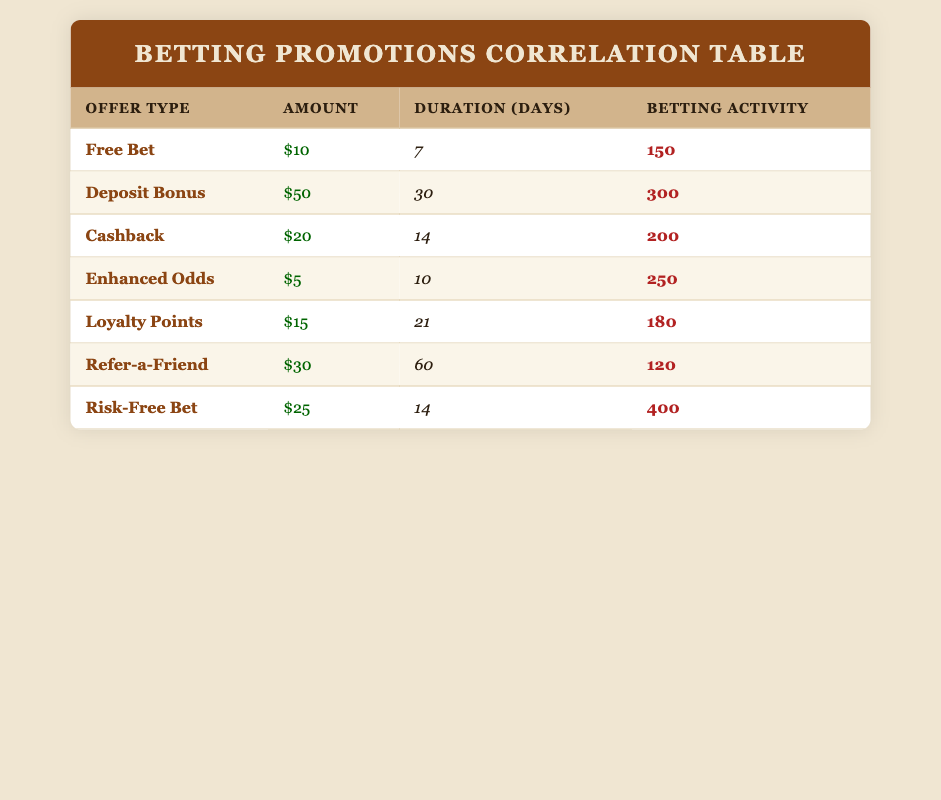What is the betting activity for the Risk-Free Bet offer? The Risk-Free Bet offer has a betting activity of 400 as shown in the table under the "Betting Activity" column for this offer type.
Answer: 400 Which promotional offer has the highest amount? Looking at the "Amount" column in the table, the Deposit Bonus with an amount of 50 is the highest when compared to the other promotional offers.
Answer: Deposit Bonus Is the duration of the Cashback offer longer than the Free Bet offer? The Cashback offer has a duration of 14 days, while the Free Bet offer has a duration of 7 days. Since 14 is greater than 7, the statement is true.
Answer: Yes What is the total betting activity of all offers combined? To find the total, we sum up all the betting activity values: 150 + 300 + 200 + 250 + 180 + 120 + 400 = 1600. Thus, the total betting activity is 1600.
Answer: 1600 Does the amount of the Refer-a-Friend offer exceed the amount of the Loyalty Points offer? The Refer-a-Friend offer has an amount of 30, while the Loyalty Points offer has an amount of 15. Since 30 is greater than 15, the statement is true.
Answer: Yes What is the average amount offered across all promotions? To get the average amount, we first sum the amounts: 10 + 50 + 20 + 5 + 15 + 30 + 25 = 155. There are 7 promotional offers, so the average is 155 / 7, which equals approximately 22.14.
Answer: 22.14 Which promotional offer has a betting activity between 150 and 250? By examining the "Betting Activity" column, the offers with activities in this range are the Free Bet (150), Cashback (200), and Loyalty Points (180).
Answer: Free Bet, Cashback, Loyalty Points If we exclude the Risk-Free Bet, what is the maximum betting activity from the remaining offers? The betting activities excluding the Risk-Free Bet (400) are: 150, 300, 200, 250, 180, and 120. The maximum among these values is 300, found with the Deposit Bonus.
Answer: 300 